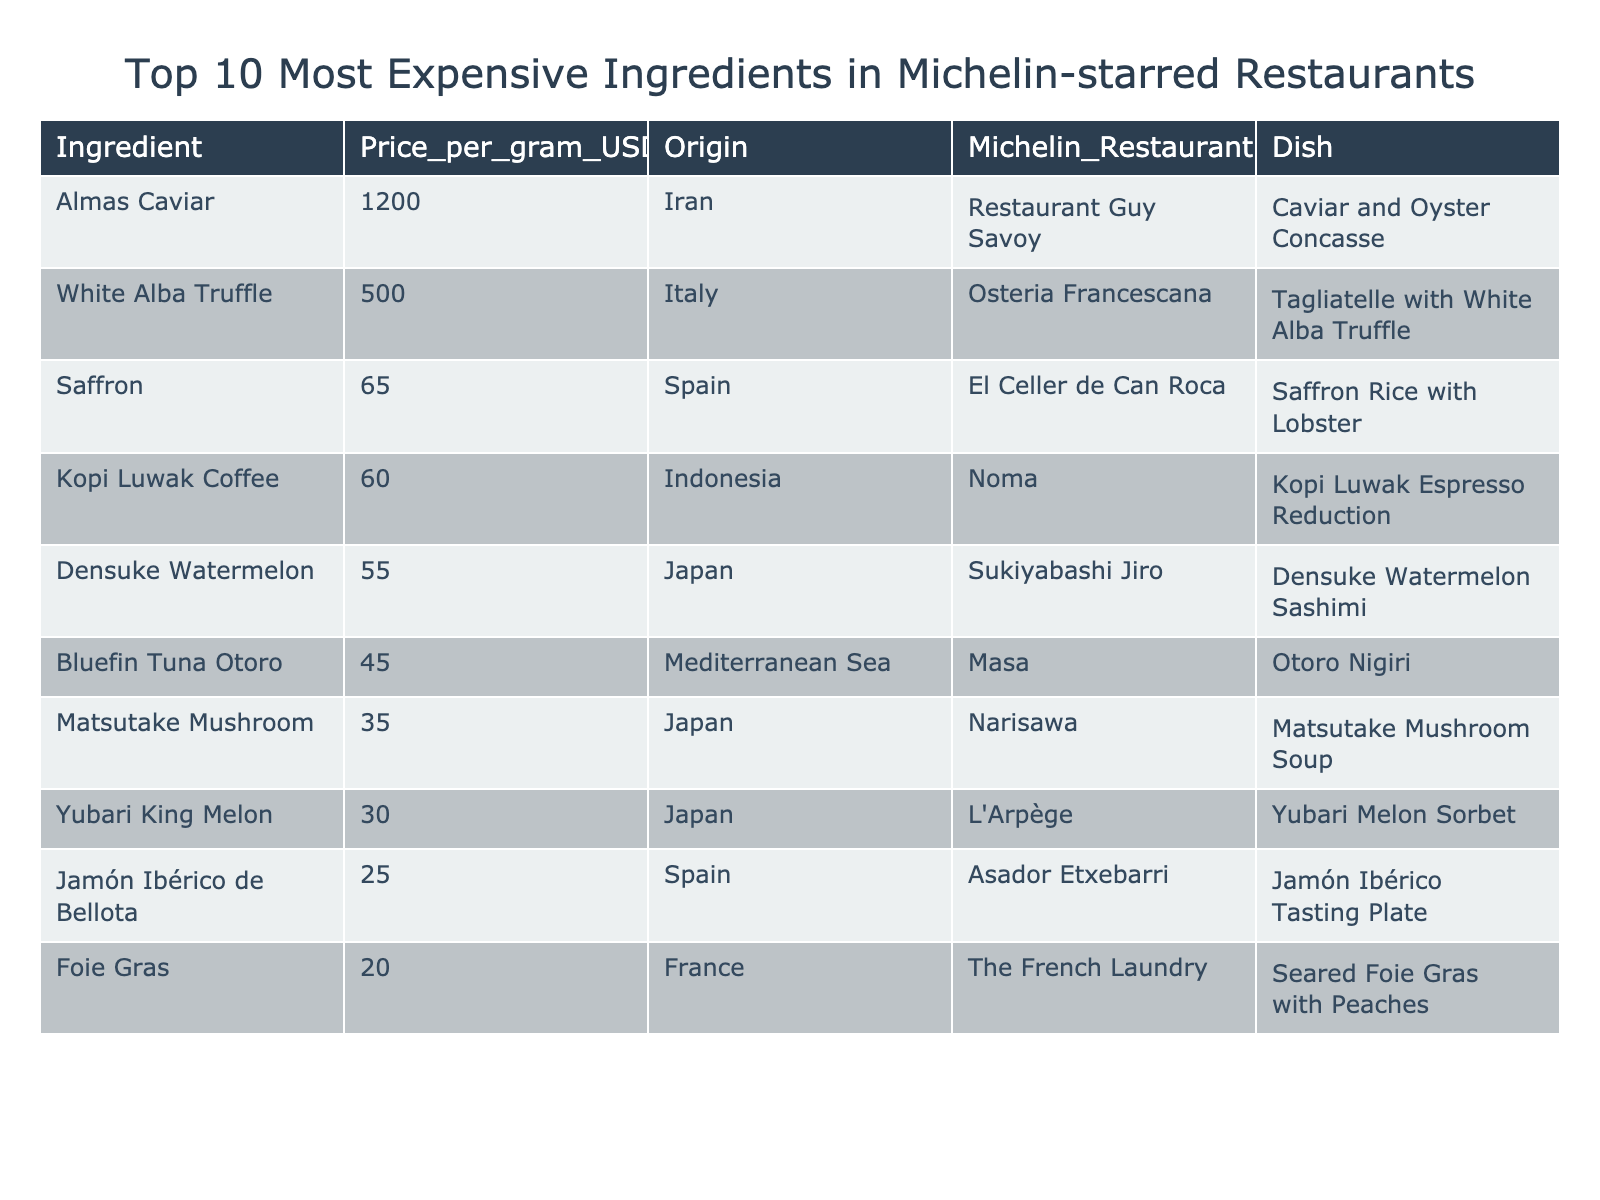What is the price per gram of Almas Caviar? The table shows the price listed for Almas Caviar under the "Price_per_gram_USD" column as 1200.
Answer: 1200 Which ingredient has the second highest price per gram? The second highest price per gram after Almas Caviar (1200) is for White Alba Truffle at 500.
Answer: White Alba Truffle How many ingredients are listed from Japan? In the table, there are three ingredients from Japan: Densuke Watermelon, Matsutake Mushroom, and Yubari King Melon.
Answer: 3 What is the total price per gram of the top three most expensive ingredients? The top three ingredients by price per gram are Almas Caviar (1200), White Alba Truffle (500), and Saffron (65). Their total is 1200 + 500 + 65 = 1765.
Answer: 1765 Is Foie Gras the least expensive ingredient listed? Yes, Foie Gras at 20 is the least expensive ingredient shown in the table.
Answer: Yes Which ingredient from France has the lowest price per gram? The only ingredient from France listed is Foie Gras, which has the lowest price of 20 per gram.
Answer: Foie Gras If you were to average the prices of all ingredients, what would be the average price per gram? The prices are (1200 + 500 + 65 + 60 + 55 + 45 + 35 + 30 + 25 + 20) = 2025. Dividing by the 10 ingredients gives an average of 202.5.
Answer: 202.5 How much more expensive is White Alba Truffle than Jamón Ibérico de Bellota? The price of White Alba Truffle is 500, while Jamón Ibérico de Bellota is 25. The difference is 500 - 25 = 475.
Answer: 475 What origin does the ingredient Kopi Luwak Coffee come from? According to the table, Kopi Luwak Coffee is listed with the origin as Indonesia.
Answer: Indonesia Does the Densuke Watermelon have a higher price per gram than Bluefin Tuna Otoro? Yes, Densuke Watermelon is priced at 55, which is higher than Bluefin Tuna Otoro priced at 45.
Answer: Yes What dish is associated with the Matsutake Mushroom ingredient? Matsutake Mushroom is associated with the dish "Matsutake Mushroom Soup" as noted in the table.
Answer: Matsutake Mushroom Soup 